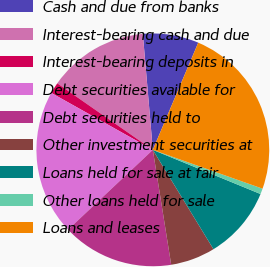Convert chart to OTSL. <chart><loc_0><loc_0><loc_500><loc_500><pie_chart><fcel>Cash and due from banks<fcel>Interest-bearing cash and due<fcel>Interest-bearing deposits in<fcel>Debt securities available for<fcel>Debt securities held to<fcel>Other investment securities at<fcel>Loans held for sale at fair<fcel>Other loans held for sale<fcel>Loans and leases<nl><fcel>7.75%<fcel>13.95%<fcel>1.55%<fcel>20.15%<fcel>15.5%<fcel>6.2%<fcel>10.08%<fcel>0.78%<fcel>24.03%<nl></chart> 